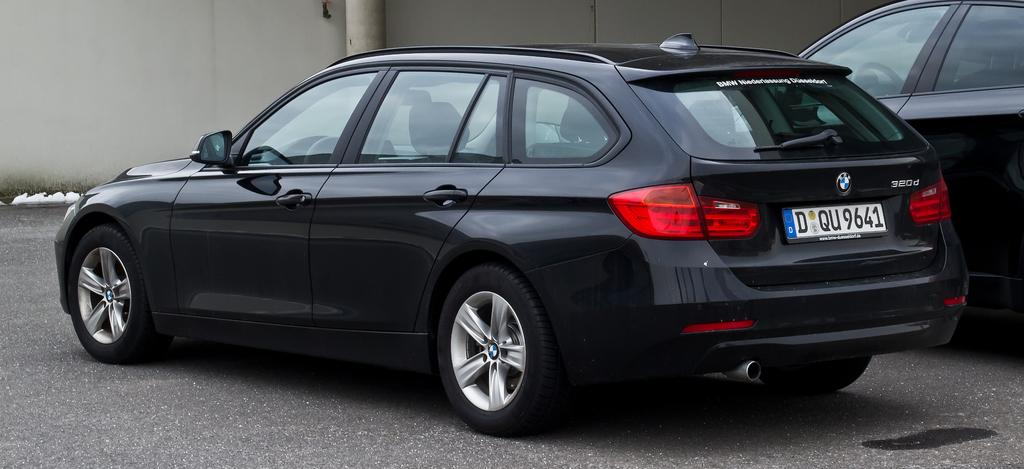What is happening on the road in the image? There are vehicles on the road in the image. What can be seen in the background of the image? There is a wall visible in the background of the image. How many snakes are slithering on the wall in the image? There are no snakes present in the image; the wall is visible in the background, but no snakes are depicted. 